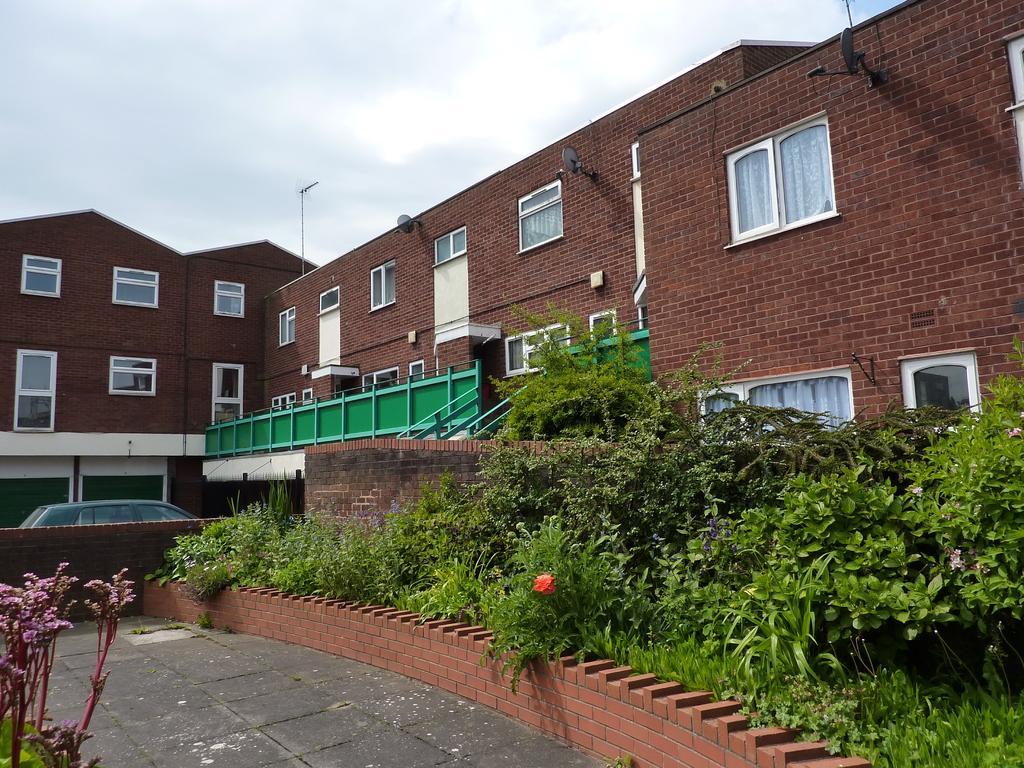Please provide a concise description of this image. This image is taken in outdoors. In this image there is a building with walls, windows and doors. In the bottom of the image there is a floor. In the right side of the image there is a grass and plants. In the left side of the image there is a plant. At the top of the image there is a sky with clouds. In this image there is a car in front of the building. 